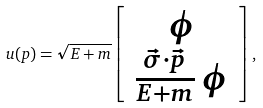Convert formula to latex. <formula><loc_0><loc_0><loc_500><loc_500>u ( p ) = \sqrt { E + m } \left [ \begin{array} { c } \phi \\ \frac { \vec { \sigma } \cdot \vec { p } } { E + m } \, \phi \end{array} \right ] ,</formula> 